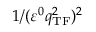Convert formula to latex. <formula><loc_0><loc_0><loc_500><loc_500>1 / ( \varepsilon ^ { 0 } q _ { T F } ^ { 2 } ) ^ { 2 }</formula> 